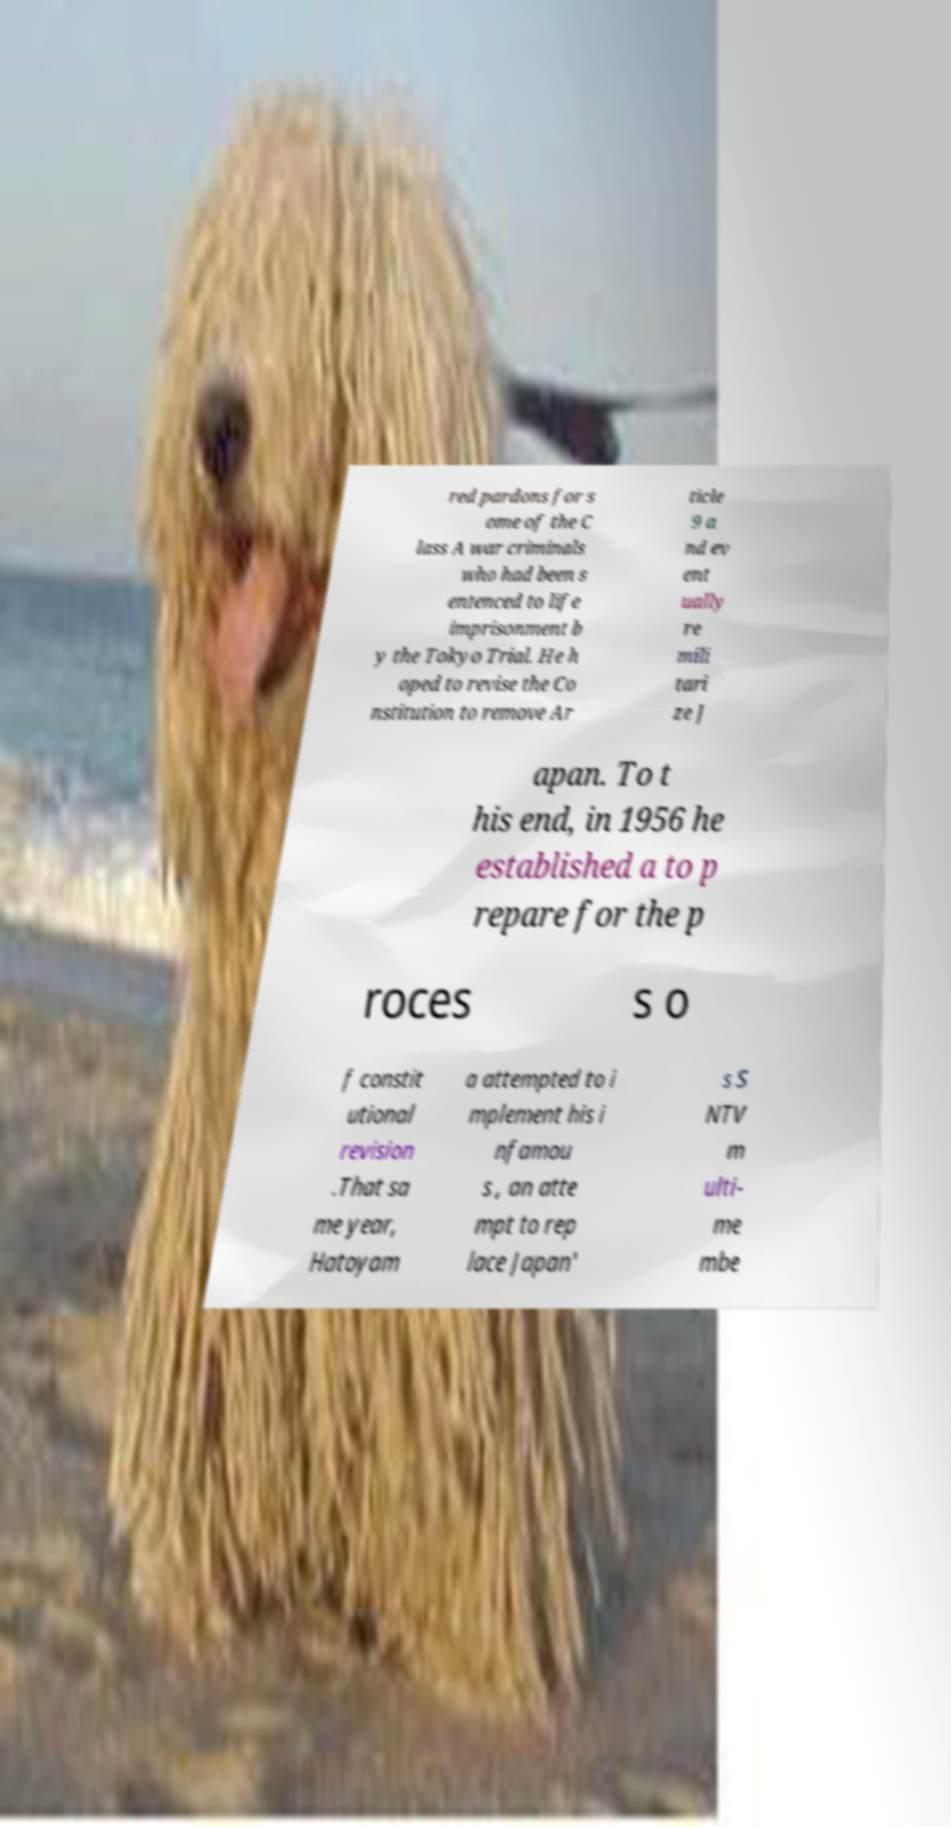Please identify and transcribe the text found in this image. red pardons for s ome of the C lass A war criminals who had been s entenced to life imprisonment b y the Tokyo Trial. He h oped to revise the Co nstitution to remove Ar ticle 9 a nd ev ent ually re mili tari ze J apan. To t his end, in 1956 he established a to p repare for the p roces s o f constit utional revision .That sa me year, Hatoyam a attempted to i mplement his i nfamou s , an atte mpt to rep lace Japan' s S NTV m ulti- me mbe 